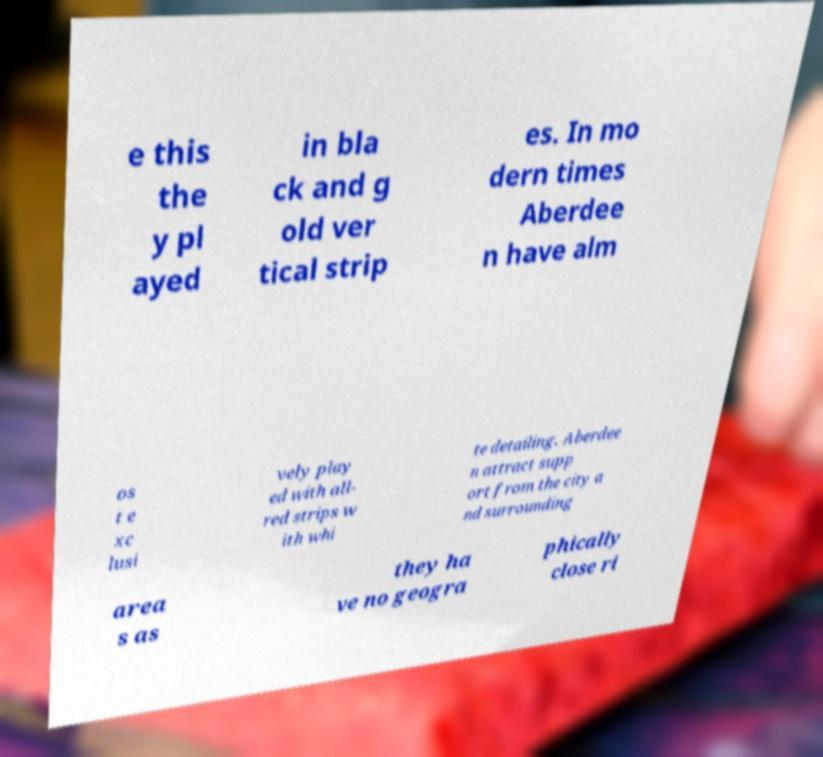Can you read and provide the text displayed in the image?This photo seems to have some interesting text. Can you extract and type it out for me? e this the y pl ayed in bla ck and g old ver tical strip es. In mo dern times Aberdee n have alm os t e xc lusi vely play ed with all- red strips w ith whi te detailing. Aberdee n attract supp ort from the city a nd surrounding area s as they ha ve no geogra phically close ri 